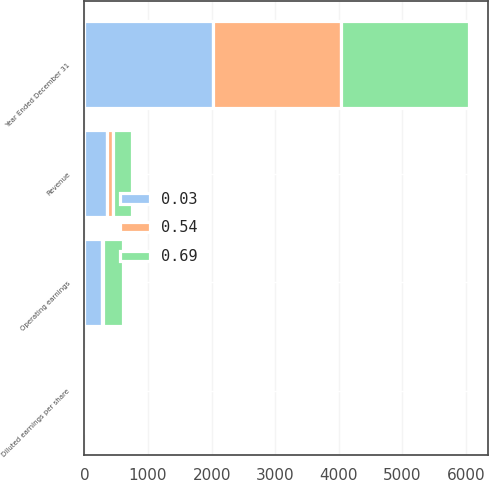<chart> <loc_0><loc_0><loc_500><loc_500><stacked_bar_chart><ecel><fcel>Year Ended December 31<fcel>Revenue<fcel>Operating earnings<fcel>Diluted earnings per share<nl><fcel>0.69<fcel>2017<fcel>292<fcel>323<fcel>0.69<nl><fcel>0.54<fcel>2016<fcel>95<fcel>16<fcel>0.03<nl><fcel>0.03<fcel>2015<fcel>356<fcel>271<fcel>0.54<nl></chart> 